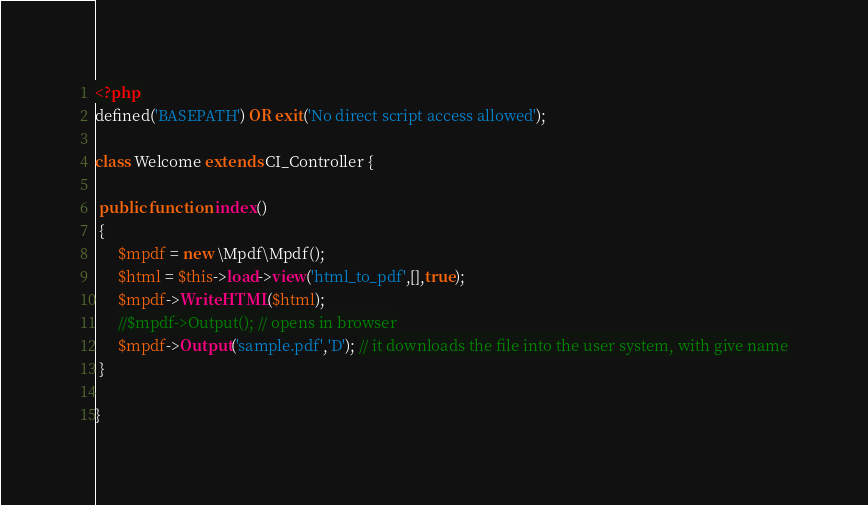<code> <loc_0><loc_0><loc_500><loc_500><_PHP_><?php
defined('BASEPATH') OR exit('No direct script access allowed');
 
class Welcome extends CI_Controller {
 
 public function index()
 {
      $mpdf = new \Mpdf\Mpdf();
      $html = $this->load->view('html_to_pdf',[],true);
      $mpdf->WriteHTML($html);
      //$mpdf->Output(); // opens in browser
      $mpdf->Output('sample.pdf','D'); // it downloads the file into the user system, with give name
 }
 
}
</code> 